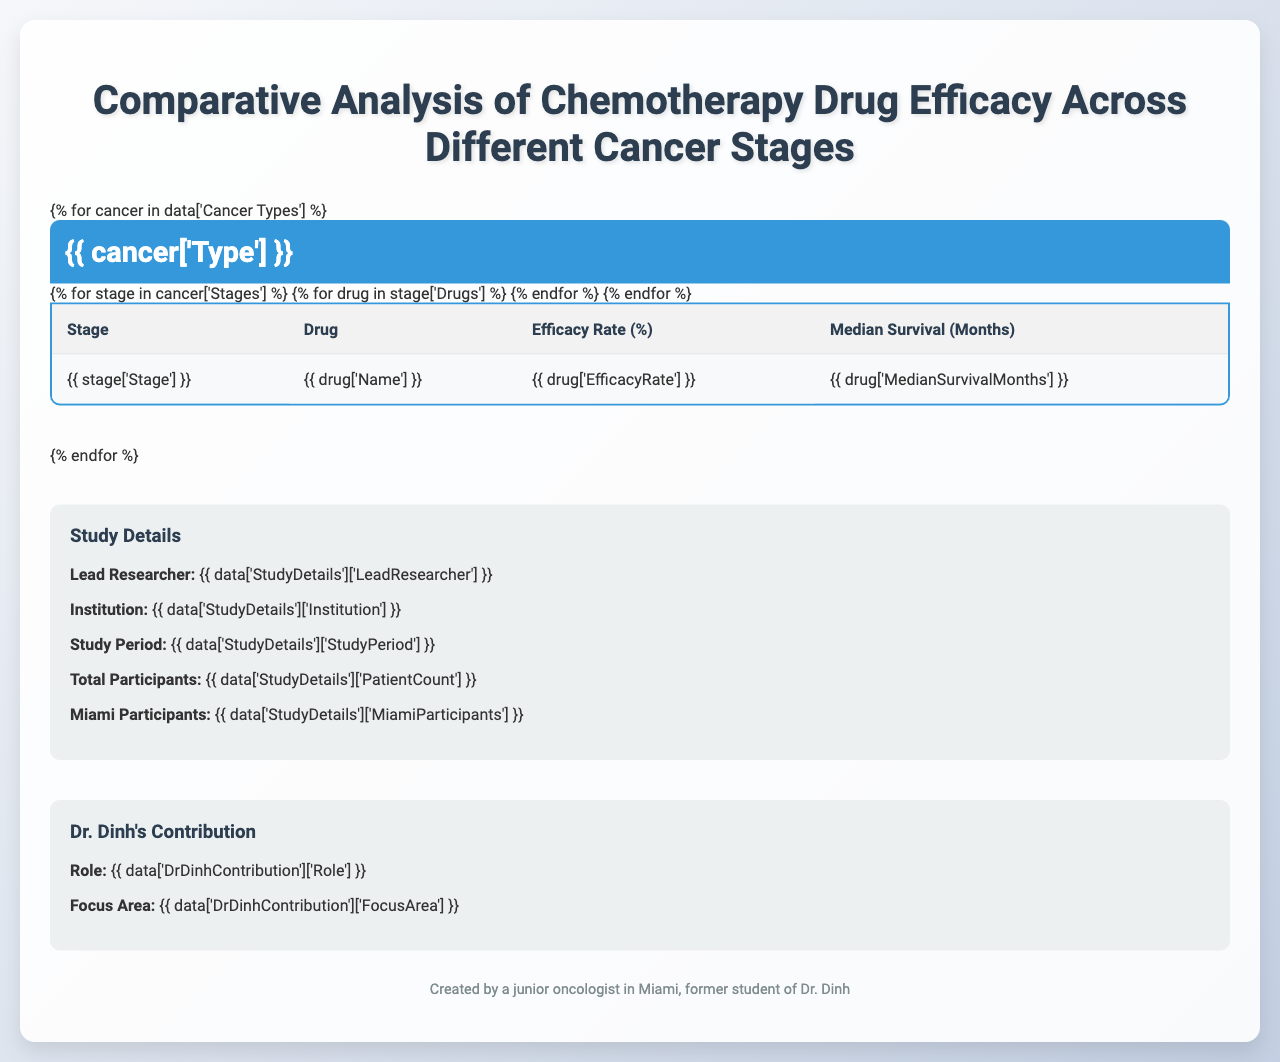What is the efficacy rate of Paclitaxel for Stage I Breast Cancer? The table indicates that for Stage I Breast Cancer, the efficacy rate of Paclitaxel is listed as 82%.
Answer: 82% Which drug has the highest median survival months in Stage III Colorectal Cancer? In Stage III Colorectal Cancer, FOLFOX has a median survival of 42 months, while Capecitabine has 39 months. FOLFOX has the higher value.
Answer: FOLFOX Does Cisplatin have a higher efficacy rate in Stage II Lung Cancer compared to Stage IV Lung Cancer? For Stage II Lung Cancer, Cisplatin has an efficacy rate of 68%, while for Stage IV Lung Cancer, it drops to 45%. Since 68% is greater than 45%, the statement is true.
Answer: Yes What is the difference in median survival months between Doxorubicin for Stage I and Stage III Breast Cancer? For Stage I, Doxorubicin's median survival is 60 months, and for Stage III, it is 42 months. The difference is 60 - 42 = 18 months.
Answer: 18 months Which drug has the lowest efficacy rate in this comparative analysis? The table shows that in Stage IV Lung Cancer, Gemcitabine has the lowest efficacy rate at 50%.
Answer: 50% What is the average efficacy rate of all drugs used for Breast Cancer? The efficacy rates for Breast Cancer drugs are 78% (Doxorubicin) and 82% (Paclitaxel). The average is (78 + 82) / 2 = 80%.
Answer: 80% Is the efficacy rate of Capecitabine higher in Stage II or Stage III Colorectal Cancer? Capecitabine has an efficacy rate of 70% in Stage II and 60% in Stage III. Since 70% is greater than 60%, it is higher in Stage II.
Answer: Stage II What is the total patient count involved in the study? The study details mention that there are a total of 1250 participants in the study.
Answer: 1250 Which cancer type shows the highest efficacy rate for chemotherapy in Stage I? In Stage I of Breast Cancer, the highest efficacy rate is from Paclitaxel at 82%, the table does not list a Stage I for Lung or Colorectal Cancer.
Answer: Paclitaxel (82%) What can be inferred about the efficacy of chemotherapy drugs as cancer stages progress for Lung Cancer? The table shows that as the cancer stage progresses from Stage II to Stage IV for Lung Cancer, both Cisplatin and Gemcitabine have decreased efficacy rates. This indicates a decline in drug effectiveness as the disease progresses.
Answer: The efficacy decreases 